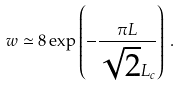Convert formula to latex. <formula><loc_0><loc_0><loc_500><loc_500>w \simeq 8 \exp \left ( - \frac { \pi L } { \sqrt { 2 } L _ { c } } \right ) \, .</formula> 